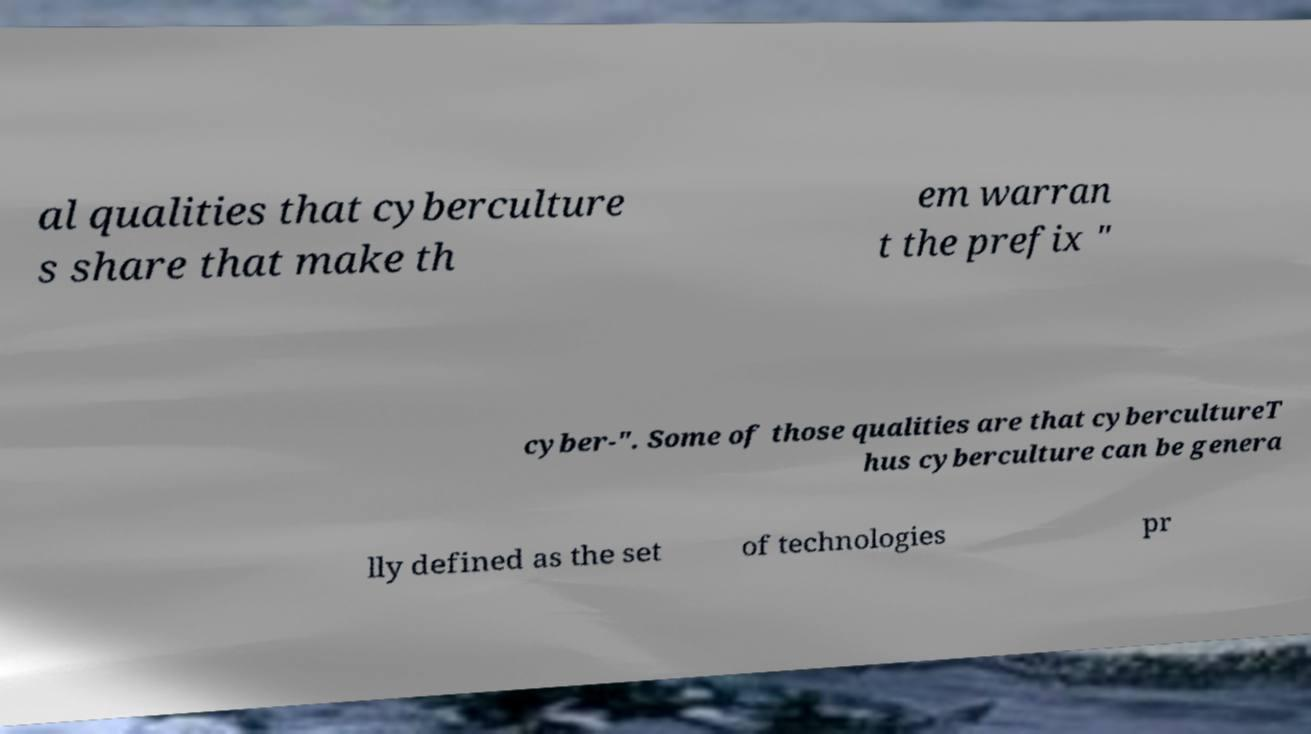Can you read and provide the text displayed in the image?This photo seems to have some interesting text. Can you extract and type it out for me? al qualities that cyberculture s share that make th em warran t the prefix " cyber-". Some of those qualities are that cybercultureT hus cyberculture can be genera lly defined as the set of technologies pr 